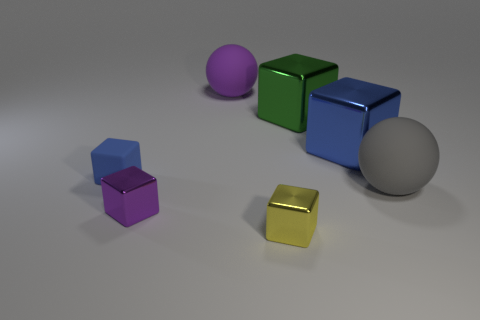What size is the metallic cube that is the same color as the small rubber thing?
Ensure brevity in your answer.  Large. The matte object that is the same size as the purple cube is what color?
Your answer should be very brief. Blue. Is the number of large gray matte things behind the gray rubber object less than the number of large purple rubber spheres to the right of the small purple block?
Provide a succinct answer. Yes. There is a big green metal cube that is in front of the big rubber sphere that is to the left of the large green cube; what number of blue cubes are in front of it?
Offer a very short reply. 2. There is another thing that is the same shape as the large gray thing; what is its size?
Offer a very short reply. Large. Are there fewer gray balls behind the small rubber thing than gray matte blocks?
Ensure brevity in your answer.  No. Do the purple rubber thing and the large gray matte object have the same shape?
Provide a succinct answer. Yes. The other big metal object that is the same shape as the big green thing is what color?
Your answer should be compact. Blue. What number of big things have the same color as the matte cube?
Provide a short and direct response. 1. How many objects are blocks in front of the large gray ball or big purple rubber spheres?
Your answer should be compact. 3. 